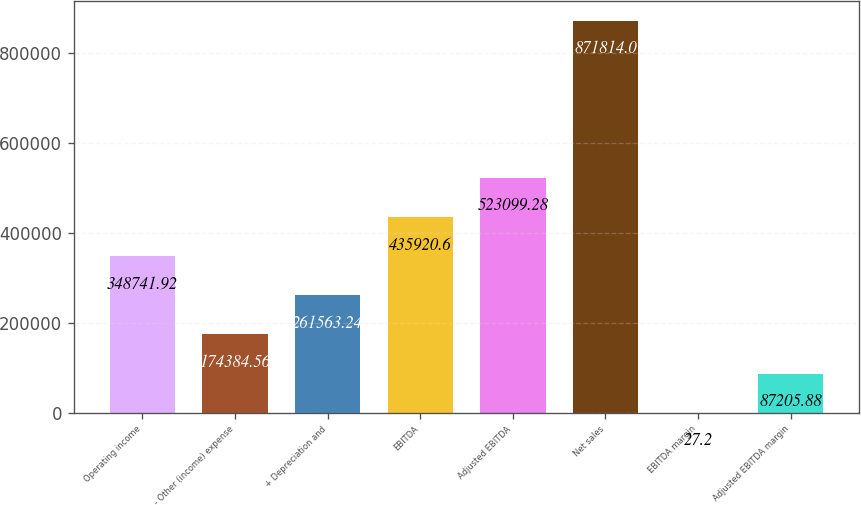Convert chart to OTSL. <chart><loc_0><loc_0><loc_500><loc_500><bar_chart><fcel>Operating income<fcel>- Other (income) expense<fcel>+ Depreciation and<fcel>EBITDA<fcel>Adjusted EBITDA<fcel>Net sales<fcel>EBITDA margin<fcel>Adjusted EBITDA margin<nl><fcel>348742<fcel>174385<fcel>261563<fcel>435921<fcel>523099<fcel>871814<fcel>27.2<fcel>87205.9<nl></chart> 